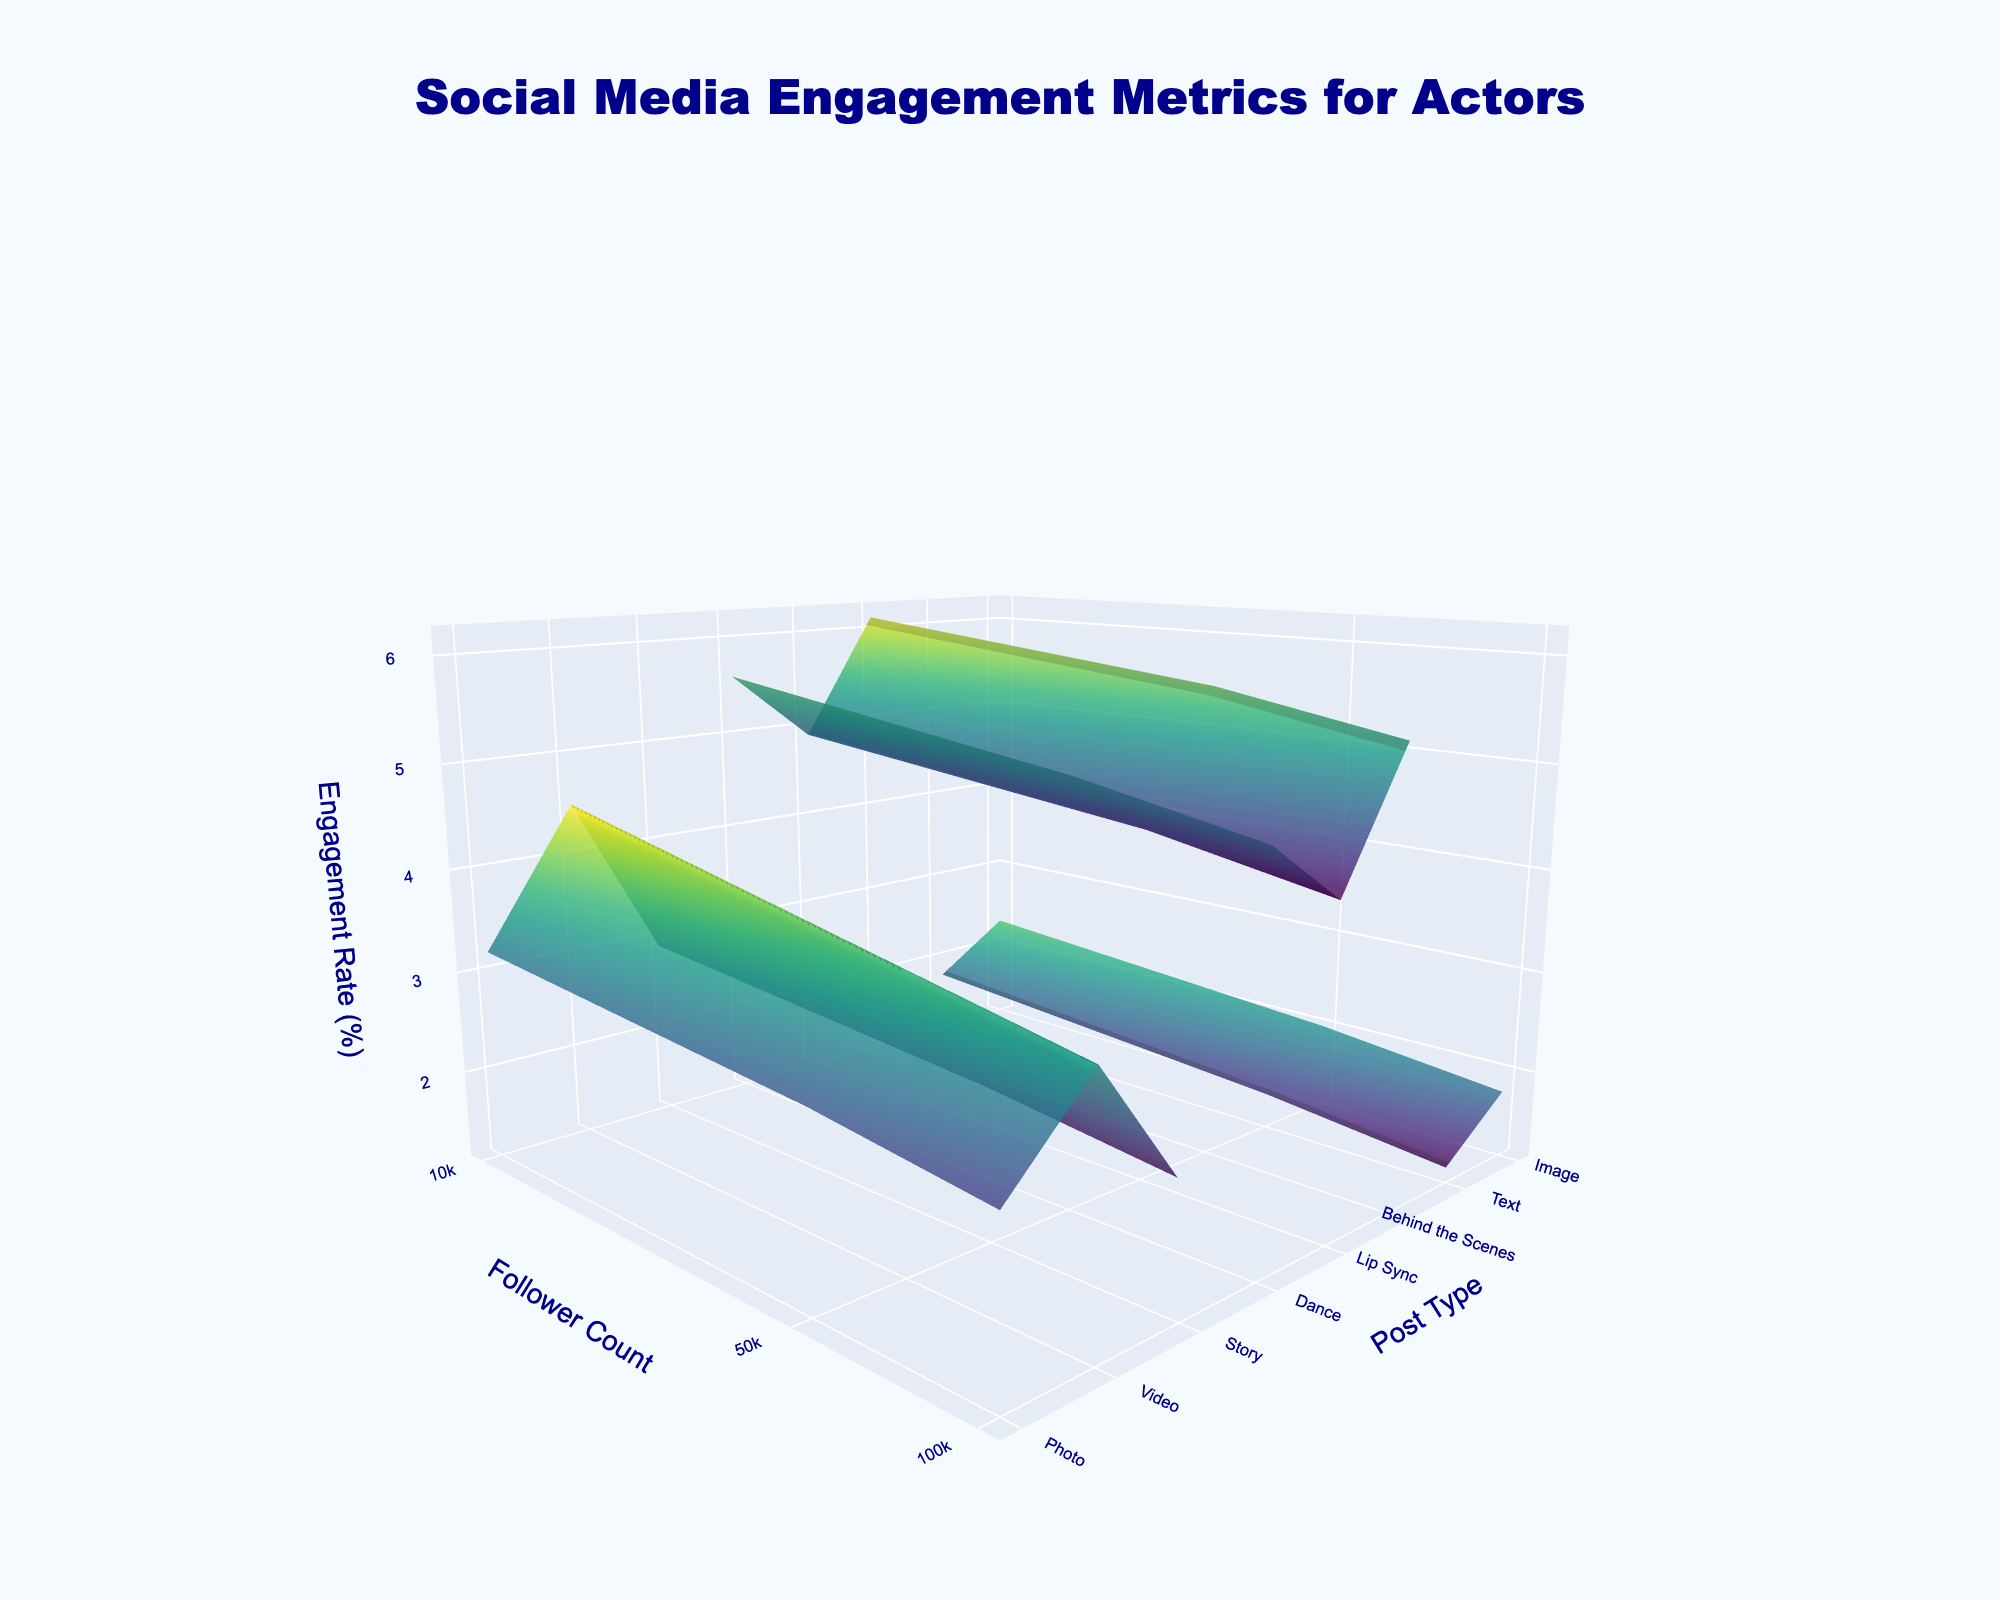How many platforms are visualized in the plot? Look for distinct surfaces in the plot, each representing a different platform. The "Platform" column in the data indicates three unique platforms: Instagram, TikTok, and Twitter.
Answer: 3 What is the highest engagement rate observed on Instagram? Focus on the highest z-axis value for the engagement rates of different post types and follower counts on the Instagram surface. The highest engagement rate seen is for videos with 10,000 followers, which is 4.5%.
Answer: 4.5% Which post type on TikTok has the highest engagement rate? Examine the top elevation point on the TikTok surface to see which post type and follower count have the highest engagement rate. "Behind the Scenes" posts with 10,000 followers have the highest engagement rate of 6.2%.
Answer: Behind the Scenes Do videos on Instagram with 50,000 followers have higher engagement rates than videos on Twitter with the same follower count? Compare the heights of the surfaces for Instagram and Twitter at the follower count of 50,000 for the post type "Video". Instagram has an engagement rate of 3.8% and Twitter has 2.4%, making Instagram higher.
Answer: Yes Is there any platform where photo engagement rates increase as follower counts increase? Compare the z-axis values for photo engagement rates across different follower counts for each platform. For Instagram, engagement rates decrease (3.2% to 2.9% to 2.7%), indicating no increase with rising followers. TikTok and Twitter don't have "Photo" post types.
Answer: No What is the average engagement rate for text posts on Twitter across all follower counts? Calculate the average by summing up engagement rates for text posts on Twitter (1.8%, 1.5%, 1.3%) and then dividing by the number of data points (3). Average = (1.8 + 1.5 + 1.3) / 3 = 1.53.
Answer: 1.53 Which platform shows the greatest variance in engagement rates for different post types? Analyze the spread of engagement rates across different post types within each platform's surface. TikTok generally has the highest variances, with rates ranging from 4.2% to 6.2%.
Answer: TikTok How does the engagement rate for TikTok lip sync posts change as follower count increases? Look at the specific z-axis values for "Lip Sync" posts on TikTok across follower counts 10,000, 50,000, and 100,000: 4.9%, 4.5%, and 4.2%. The engagement rate decreases with increasing followers.
Answer: Decreases Between Instagram and Twitter, which platform has a higher engagement rate for "Video" posts with 100,000 followers? Check the z-axis heights for "Video" posts with 100,000 followers for both Instagram and Twitter. Instagram rates at 3.5%, while Twitter rates at 2.2%.
Answer: Instagram 